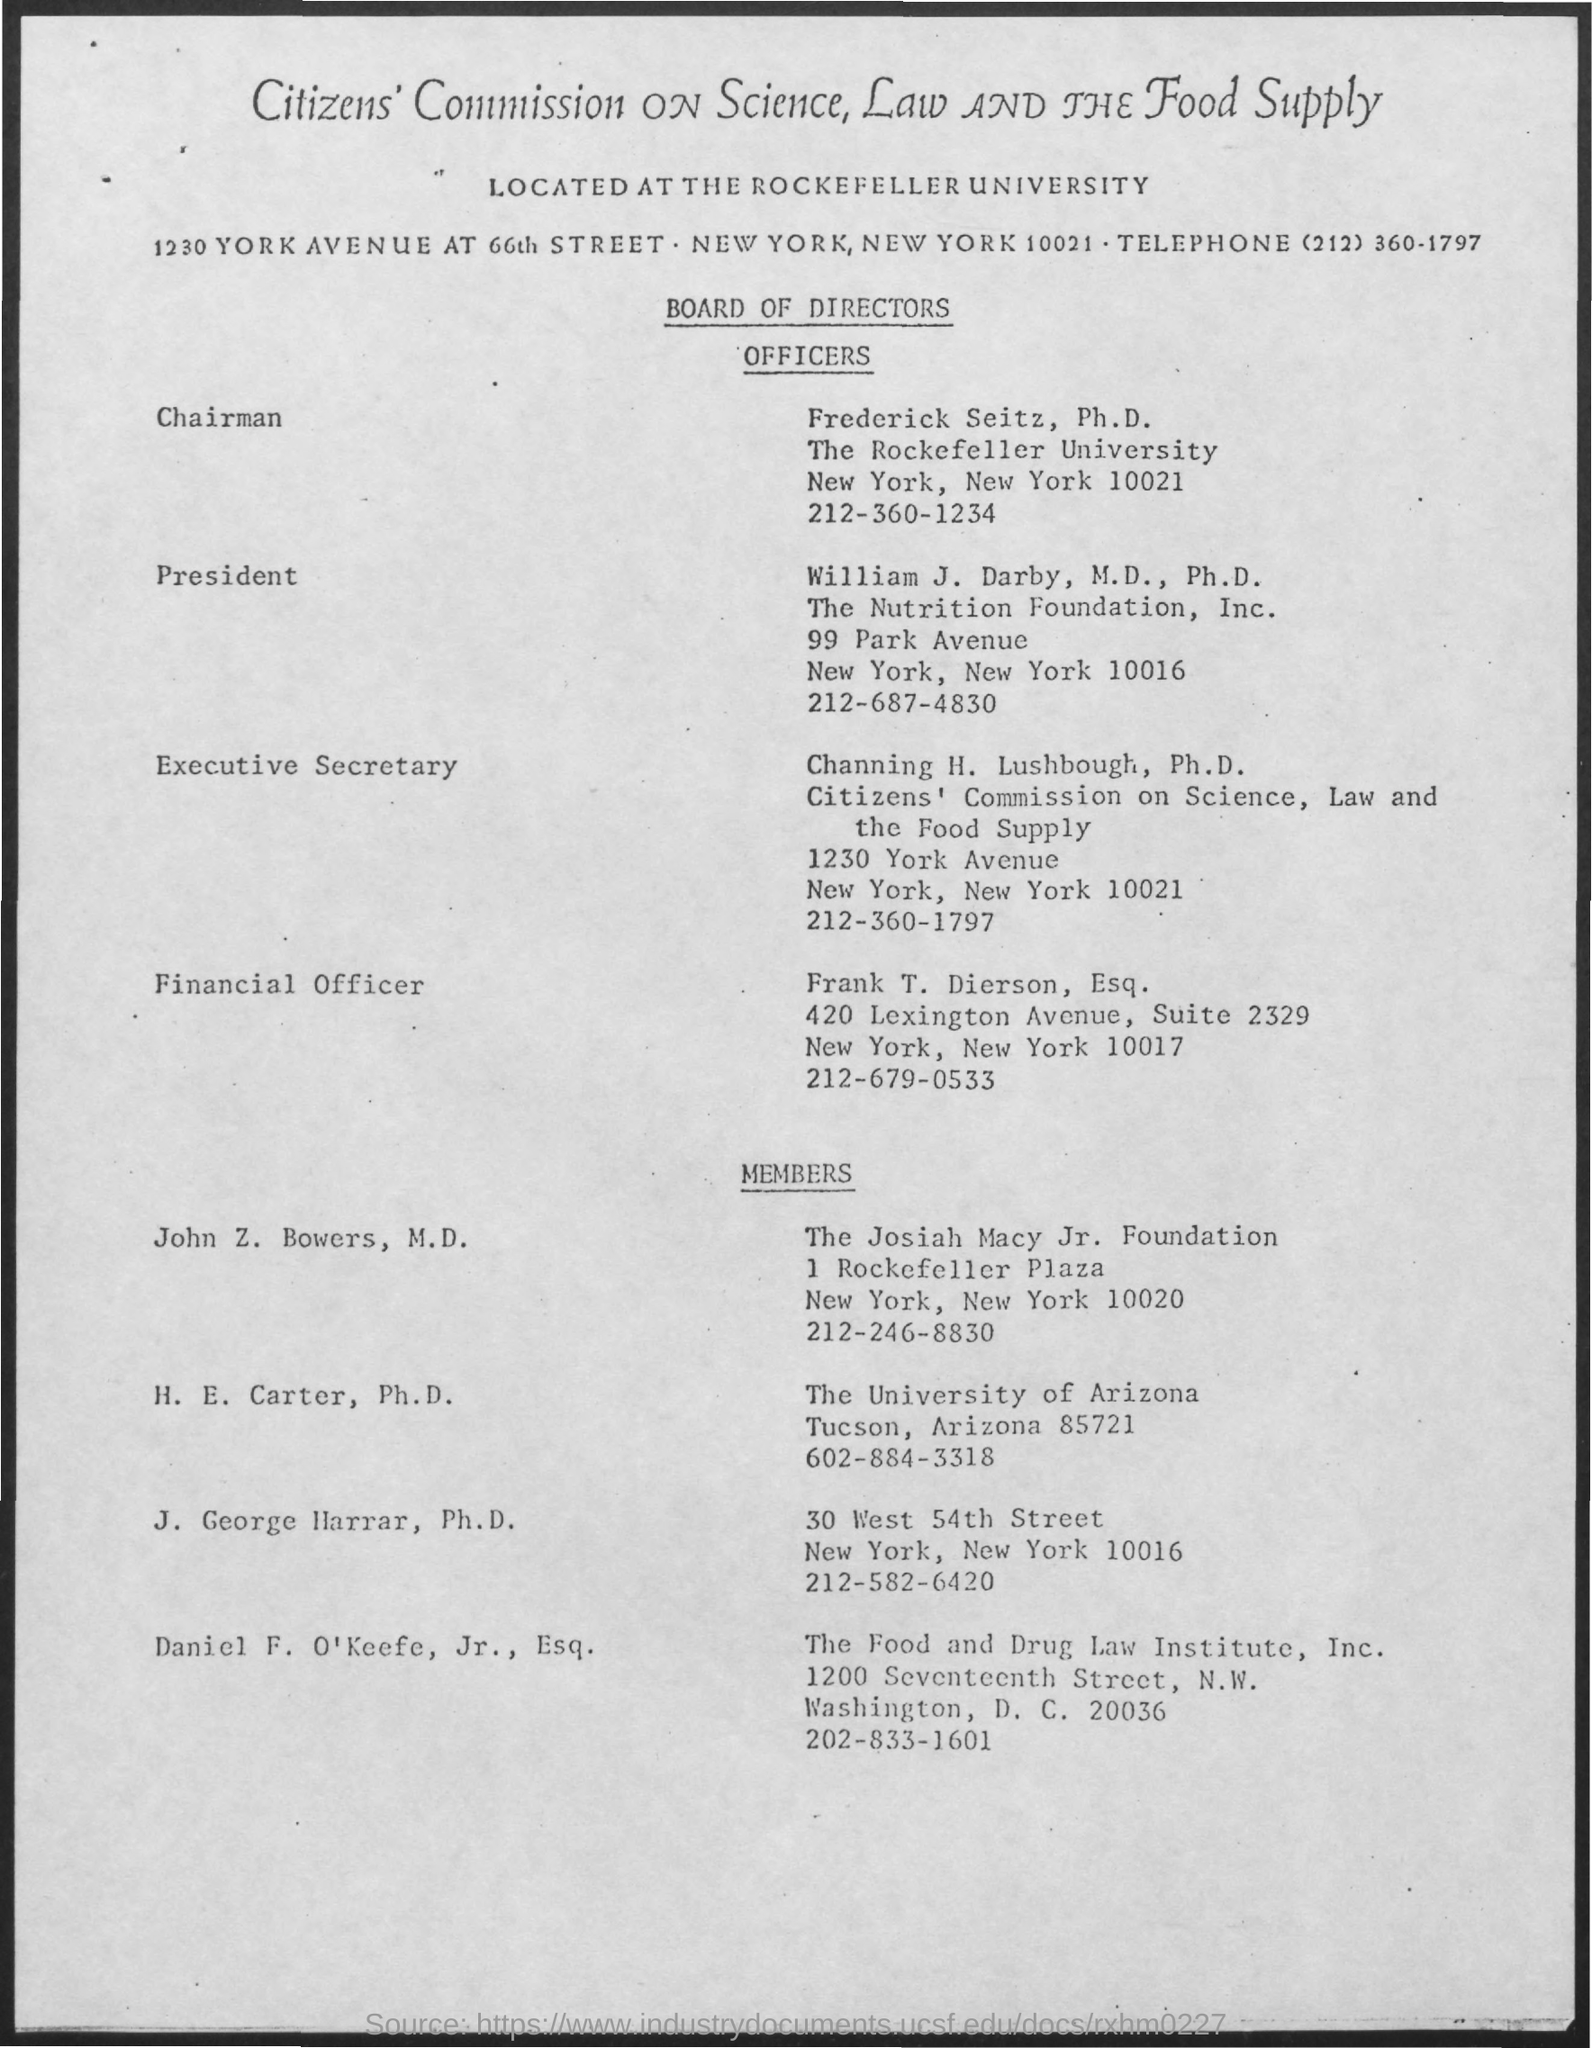Highlight a few significant elements in this photo. The name of the financial officer mentioned is Frank T. Dierson. The executive secretary's name is Channing H. Lushbough. 